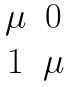<formula> <loc_0><loc_0><loc_500><loc_500>\begin{matrix} \mu & 0 \\ 1 & \mu \end{matrix}</formula> 